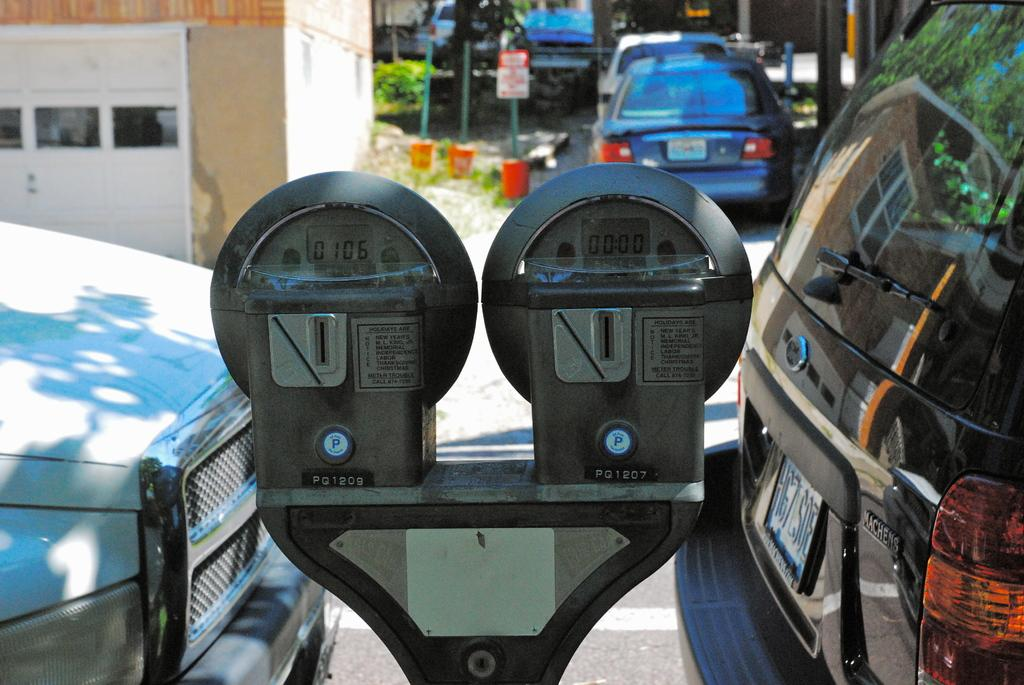<image>
Present a compact description of the photo's key features. Two adjoining parking meters are labeled PQ1209 and PQ1207. 